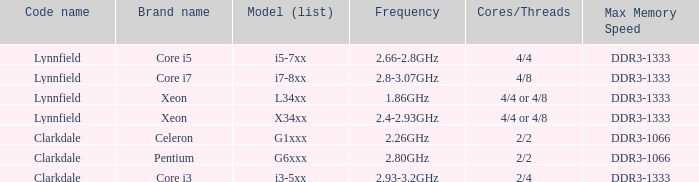Parse the table in full. {'header': ['Code name', 'Brand name', 'Model (list)', 'Frequency', 'Cores/Threads', 'Max Memory Speed'], 'rows': [['Lynnfield', 'Core i5', 'i5-7xx', '2.66-2.8GHz', '4/4', 'DDR3-1333'], ['Lynnfield', 'Core i7', 'i7-8xx', '2.8-3.07GHz', '4/8', 'DDR3-1333'], ['Lynnfield', 'Xeon', 'L34xx', '1.86GHz', '4/4 or 4/8', 'DDR3-1333'], ['Lynnfield', 'Xeon', 'X34xx', '2.4-2.93GHz', '4/4 or 4/8', 'DDR3-1333'], ['Clarkdale', 'Celeron', 'G1xxx', '2.26GHz', '2/2', 'DDR3-1066'], ['Clarkdale', 'Pentium', 'G6xxx', '2.80GHz', '2/2', 'DDR3-1066'], ['Clarkdale', 'Core i3', 'i3-5xx', '2.93-3.2GHz', '2/4', 'DDR3-1333']]} What is the frequency utilized by the pentium processor? 2.80GHz. 